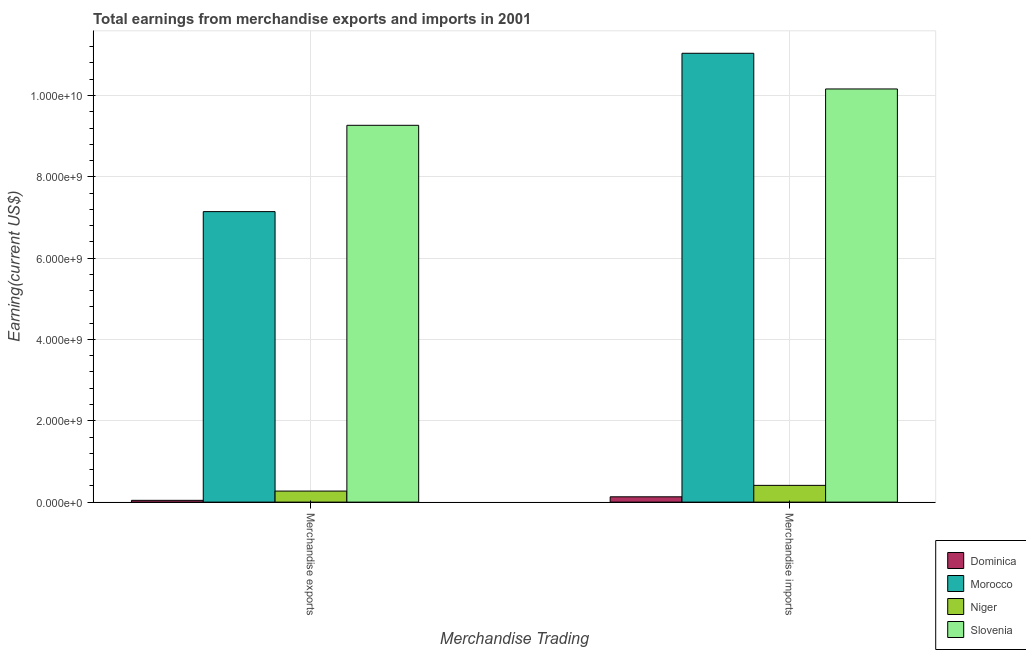How many different coloured bars are there?
Provide a succinct answer. 4. Are the number of bars per tick equal to the number of legend labels?
Offer a terse response. Yes. Are the number of bars on each tick of the X-axis equal?
Offer a terse response. Yes. What is the earnings from merchandise exports in Dominica?
Offer a terse response. 4.40e+07. Across all countries, what is the maximum earnings from merchandise exports?
Your answer should be very brief. 9.27e+09. Across all countries, what is the minimum earnings from merchandise exports?
Your answer should be compact. 4.40e+07. In which country was the earnings from merchandise imports maximum?
Ensure brevity in your answer.  Morocco. In which country was the earnings from merchandise imports minimum?
Offer a terse response. Dominica. What is the total earnings from merchandise imports in the graph?
Make the answer very short. 2.17e+1. What is the difference between the earnings from merchandise imports in Dominica and that in Slovenia?
Your answer should be very brief. -1.00e+1. What is the difference between the earnings from merchandise exports in Morocco and the earnings from merchandise imports in Dominica?
Your answer should be very brief. 7.01e+09. What is the average earnings from merchandise imports per country?
Keep it short and to the point. 5.44e+09. What is the difference between the earnings from merchandise imports and earnings from merchandise exports in Niger?
Provide a succinct answer. 1.40e+08. In how many countries, is the earnings from merchandise exports greater than 9600000000 US$?
Offer a very short reply. 0. What is the ratio of the earnings from merchandise imports in Slovenia to that in Niger?
Keep it short and to the point. 24.65. In how many countries, is the earnings from merchandise imports greater than the average earnings from merchandise imports taken over all countries?
Provide a succinct answer. 2. What does the 3rd bar from the left in Merchandise imports represents?
Provide a short and direct response. Niger. What does the 4th bar from the right in Merchandise imports represents?
Provide a short and direct response. Dominica. How many bars are there?
Your answer should be compact. 8. Are all the bars in the graph horizontal?
Give a very brief answer. No. What is the difference between two consecutive major ticks on the Y-axis?
Make the answer very short. 2.00e+09. Are the values on the major ticks of Y-axis written in scientific E-notation?
Offer a very short reply. Yes. Does the graph contain any zero values?
Your answer should be compact. No. Does the graph contain grids?
Give a very brief answer. Yes. Where does the legend appear in the graph?
Give a very brief answer. Bottom right. What is the title of the graph?
Offer a terse response. Total earnings from merchandise exports and imports in 2001. Does "Philippines" appear as one of the legend labels in the graph?
Provide a short and direct response. No. What is the label or title of the X-axis?
Keep it short and to the point. Merchandise Trading. What is the label or title of the Y-axis?
Provide a succinct answer. Earning(current US$). What is the Earning(current US$) of Dominica in Merchandise exports?
Offer a terse response. 4.40e+07. What is the Earning(current US$) in Morocco in Merchandise exports?
Your response must be concise. 7.14e+09. What is the Earning(current US$) of Niger in Merchandise exports?
Make the answer very short. 2.72e+08. What is the Earning(current US$) in Slovenia in Merchandise exports?
Make the answer very short. 9.27e+09. What is the Earning(current US$) of Dominica in Merchandise imports?
Provide a succinct answer. 1.31e+08. What is the Earning(current US$) in Morocco in Merchandise imports?
Provide a short and direct response. 1.10e+1. What is the Earning(current US$) in Niger in Merchandise imports?
Make the answer very short. 4.12e+08. What is the Earning(current US$) of Slovenia in Merchandise imports?
Your answer should be compact. 1.02e+1. Across all Merchandise Trading, what is the maximum Earning(current US$) in Dominica?
Your answer should be compact. 1.31e+08. Across all Merchandise Trading, what is the maximum Earning(current US$) of Morocco?
Keep it short and to the point. 1.10e+1. Across all Merchandise Trading, what is the maximum Earning(current US$) in Niger?
Make the answer very short. 4.12e+08. Across all Merchandise Trading, what is the maximum Earning(current US$) in Slovenia?
Provide a succinct answer. 1.02e+1. Across all Merchandise Trading, what is the minimum Earning(current US$) in Dominica?
Keep it short and to the point. 4.40e+07. Across all Merchandise Trading, what is the minimum Earning(current US$) of Morocco?
Make the answer very short. 7.14e+09. Across all Merchandise Trading, what is the minimum Earning(current US$) of Niger?
Your response must be concise. 2.72e+08. Across all Merchandise Trading, what is the minimum Earning(current US$) in Slovenia?
Provide a succinct answer. 9.27e+09. What is the total Earning(current US$) of Dominica in the graph?
Your answer should be very brief. 1.75e+08. What is the total Earning(current US$) in Morocco in the graph?
Make the answer very short. 1.82e+1. What is the total Earning(current US$) of Niger in the graph?
Your answer should be very brief. 6.84e+08. What is the total Earning(current US$) in Slovenia in the graph?
Your answer should be very brief. 1.94e+1. What is the difference between the Earning(current US$) in Dominica in Merchandise exports and that in Merchandise imports?
Keep it short and to the point. -8.70e+07. What is the difference between the Earning(current US$) of Morocco in Merchandise exports and that in Merchandise imports?
Your response must be concise. -3.89e+09. What is the difference between the Earning(current US$) in Niger in Merchandise exports and that in Merchandise imports?
Your answer should be compact. -1.40e+08. What is the difference between the Earning(current US$) of Slovenia in Merchandise exports and that in Merchandise imports?
Your answer should be compact. -8.94e+08. What is the difference between the Earning(current US$) in Dominica in Merchandise exports and the Earning(current US$) in Morocco in Merchandise imports?
Make the answer very short. -1.10e+1. What is the difference between the Earning(current US$) in Dominica in Merchandise exports and the Earning(current US$) in Niger in Merchandise imports?
Your answer should be very brief. -3.68e+08. What is the difference between the Earning(current US$) of Dominica in Merchandise exports and the Earning(current US$) of Slovenia in Merchandise imports?
Your answer should be compact. -1.01e+1. What is the difference between the Earning(current US$) in Morocco in Merchandise exports and the Earning(current US$) in Niger in Merchandise imports?
Offer a very short reply. 6.73e+09. What is the difference between the Earning(current US$) in Morocco in Merchandise exports and the Earning(current US$) in Slovenia in Merchandise imports?
Keep it short and to the point. -3.02e+09. What is the difference between the Earning(current US$) of Niger in Merchandise exports and the Earning(current US$) of Slovenia in Merchandise imports?
Give a very brief answer. -9.89e+09. What is the average Earning(current US$) in Dominica per Merchandise Trading?
Your response must be concise. 8.75e+07. What is the average Earning(current US$) in Morocco per Merchandise Trading?
Provide a short and direct response. 9.09e+09. What is the average Earning(current US$) in Niger per Merchandise Trading?
Keep it short and to the point. 3.42e+08. What is the average Earning(current US$) in Slovenia per Merchandise Trading?
Provide a succinct answer. 9.71e+09. What is the difference between the Earning(current US$) of Dominica and Earning(current US$) of Morocco in Merchandise exports?
Give a very brief answer. -7.10e+09. What is the difference between the Earning(current US$) of Dominica and Earning(current US$) of Niger in Merchandise exports?
Provide a short and direct response. -2.28e+08. What is the difference between the Earning(current US$) in Dominica and Earning(current US$) in Slovenia in Merchandise exports?
Keep it short and to the point. -9.22e+09. What is the difference between the Earning(current US$) in Morocco and Earning(current US$) in Niger in Merchandise exports?
Your answer should be compact. 6.87e+09. What is the difference between the Earning(current US$) in Morocco and Earning(current US$) in Slovenia in Merchandise exports?
Your answer should be compact. -2.12e+09. What is the difference between the Earning(current US$) of Niger and Earning(current US$) of Slovenia in Merchandise exports?
Offer a very short reply. -8.99e+09. What is the difference between the Earning(current US$) in Dominica and Earning(current US$) in Morocco in Merchandise imports?
Offer a very short reply. -1.09e+1. What is the difference between the Earning(current US$) of Dominica and Earning(current US$) of Niger in Merchandise imports?
Provide a short and direct response. -2.81e+08. What is the difference between the Earning(current US$) in Dominica and Earning(current US$) in Slovenia in Merchandise imports?
Provide a short and direct response. -1.00e+1. What is the difference between the Earning(current US$) of Morocco and Earning(current US$) of Niger in Merchandise imports?
Your answer should be very brief. 1.06e+1. What is the difference between the Earning(current US$) of Morocco and Earning(current US$) of Slovenia in Merchandise imports?
Your response must be concise. 8.78e+08. What is the difference between the Earning(current US$) in Niger and Earning(current US$) in Slovenia in Merchandise imports?
Keep it short and to the point. -9.75e+09. What is the ratio of the Earning(current US$) in Dominica in Merchandise exports to that in Merchandise imports?
Provide a succinct answer. 0.34. What is the ratio of the Earning(current US$) in Morocco in Merchandise exports to that in Merchandise imports?
Offer a very short reply. 0.65. What is the ratio of the Earning(current US$) of Niger in Merchandise exports to that in Merchandise imports?
Offer a very short reply. 0.66. What is the ratio of the Earning(current US$) of Slovenia in Merchandise exports to that in Merchandise imports?
Make the answer very short. 0.91. What is the difference between the highest and the second highest Earning(current US$) in Dominica?
Offer a very short reply. 8.70e+07. What is the difference between the highest and the second highest Earning(current US$) of Morocco?
Ensure brevity in your answer.  3.89e+09. What is the difference between the highest and the second highest Earning(current US$) in Niger?
Your answer should be compact. 1.40e+08. What is the difference between the highest and the second highest Earning(current US$) in Slovenia?
Offer a terse response. 8.94e+08. What is the difference between the highest and the lowest Earning(current US$) in Dominica?
Your response must be concise. 8.70e+07. What is the difference between the highest and the lowest Earning(current US$) of Morocco?
Provide a succinct answer. 3.89e+09. What is the difference between the highest and the lowest Earning(current US$) in Niger?
Keep it short and to the point. 1.40e+08. What is the difference between the highest and the lowest Earning(current US$) of Slovenia?
Ensure brevity in your answer.  8.94e+08. 